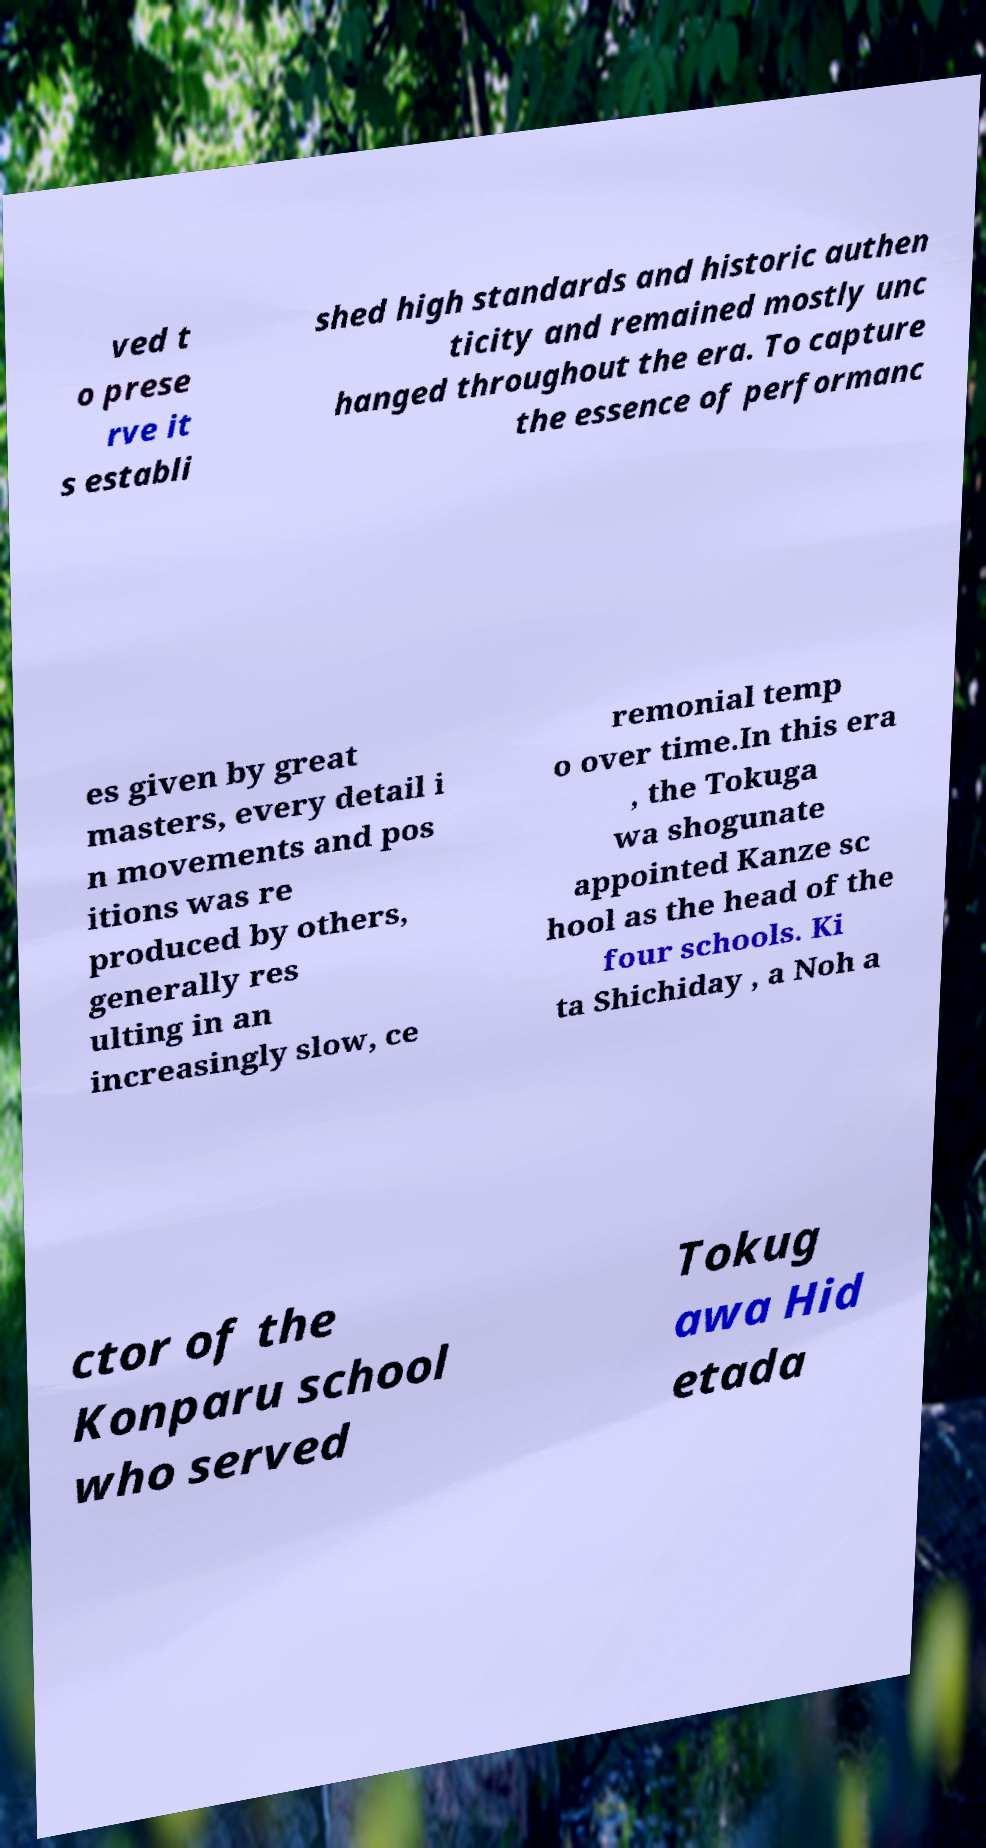There's text embedded in this image that I need extracted. Can you transcribe it verbatim? ved t o prese rve it s establi shed high standards and historic authen ticity and remained mostly unc hanged throughout the era. To capture the essence of performanc es given by great masters, every detail i n movements and pos itions was re produced by others, generally res ulting in an increasingly slow, ce remonial temp o over time.In this era , the Tokuga wa shogunate appointed Kanze sc hool as the head of the four schools. Ki ta Shichiday , a Noh a ctor of the Konparu school who served Tokug awa Hid etada 